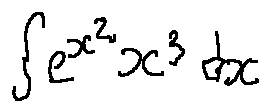<formula> <loc_0><loc_0><loc_500><loc_500>\int e ^ { x ^ { 2 } } x ^ { 3 } d x</formula> 